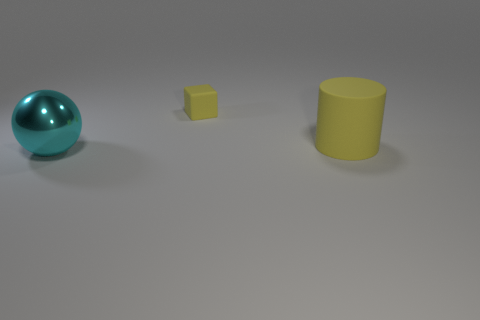Add 1 big cyan balls. How many objects exist? 4 Subtract all blocks. How many objects are left? 2 Subtract all tiny rubber cubes. Subtract all blue matte things. How many objects are left? 2 Add 3 matte objects. How many matte objects are left? 5 Add 3 big red metallic objects. How many big red metallic objects exist? 3 Subtract 0 blue cylinders. How many objects are left? 3 